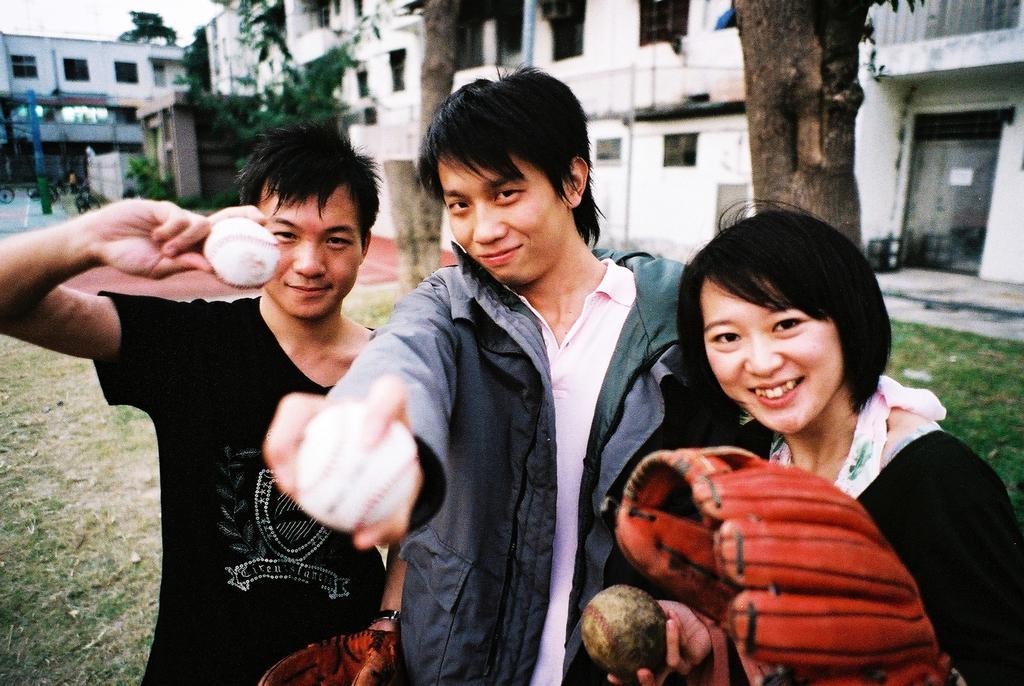How would you summarize this image in a sentence or two? In this picture there are people in the center of the image, by holding balls in their hands and there are buildings and trees in the background area of the image. 